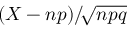Convert formula to latex. <formula><loc_0><loc_0><loc_500><loc_500>\left ( X \, - \, n p \right ) \, / \, { \sqrt { n p q } }</formula> 